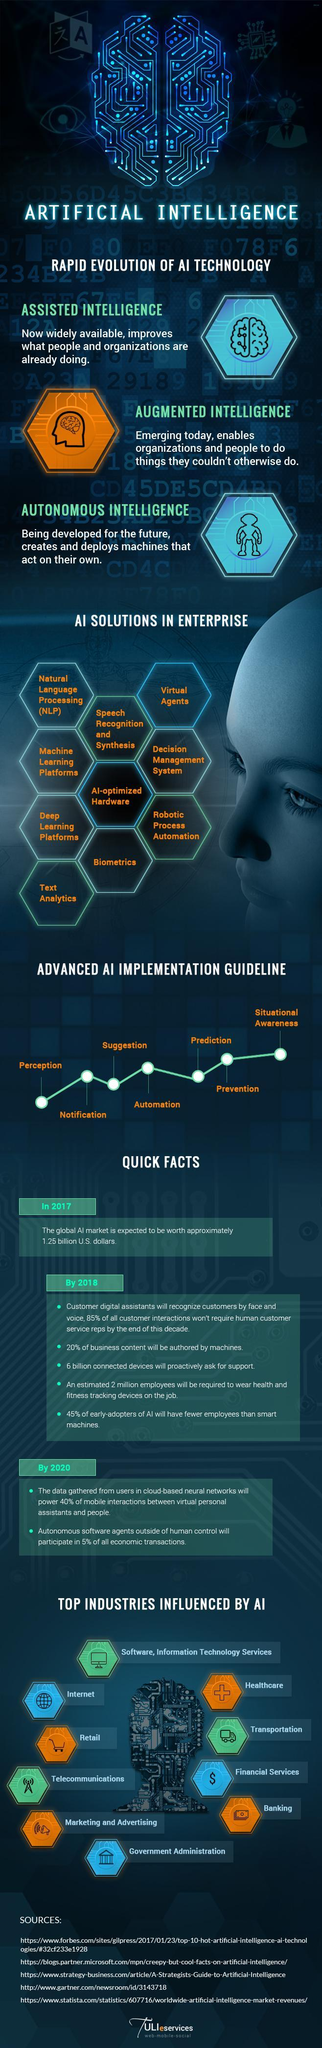Which industry is identified by the + sign
Answer the question with a short phrase. Healthcare How many industries are influenced by AI 10 What are the three types of AI technology Assisted Intelligence, Augmented Intelligence, Autonomous Intelligence Which industry is identified by the currency note Banking Which industry is identified by the $ sign Financial services How many AI solutions have been identified 10 